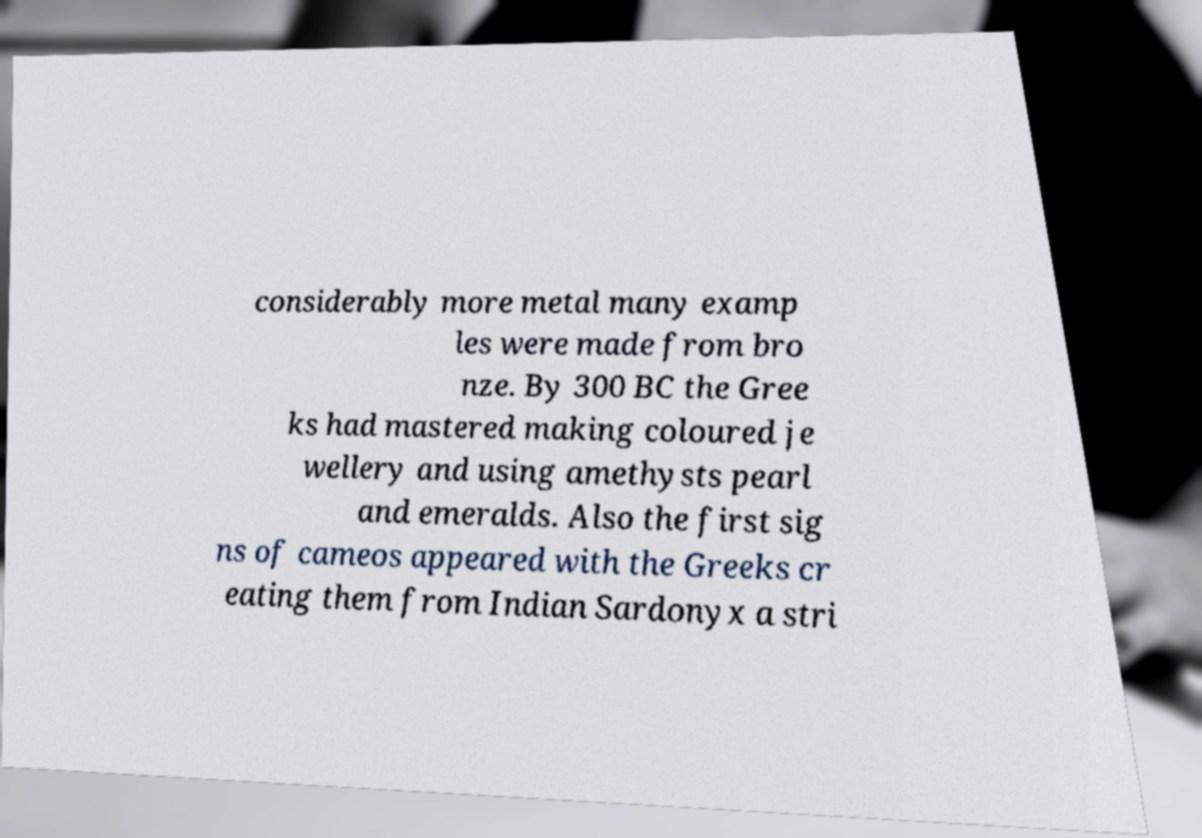What messages or text are displayed in this image? I need them in a readable, typed format. considerably more metal many examp les were made from bro nze. By 300 BC the Gree ks had mastered making coloured je wellery and using amethysts pearl and emeralds. Also the first sig ns of cameos appeared with the Greeks cr eating them from Indian Sardonyx a stri 